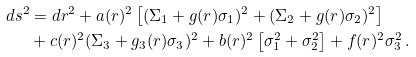Convert formula to latex. <formula><loc_0><loc_0><loc_500><loc_500>d s ^ { 2 } & = d r ^ { 2 } + a ( r ) ^ { 2 } \left [ ( \Sigma _ { 1 } + g ( r ) \sigma _ { 1 } ) ^ { 2 } + ( \Sigma _ { 2 } + g ( r ) \sigma _ { 2 } ) ^ { 2 } \right ] \\ & + c ( r ) ^ { 2 } ( \Sigma _ { 3 } + g _ { 3 } ( r ) \sigma _ { 3 } ) ^ { 2 } + b ( r ) ^ { 2 } \left [ \sigma _ { 1 } ^ { 2 } + \sigma _ { 2 } ^ { 2 } \right ] + f ( r ) ^ { 2 } \sigma _ { 3 } ^ { 2 } \, .</formula> 